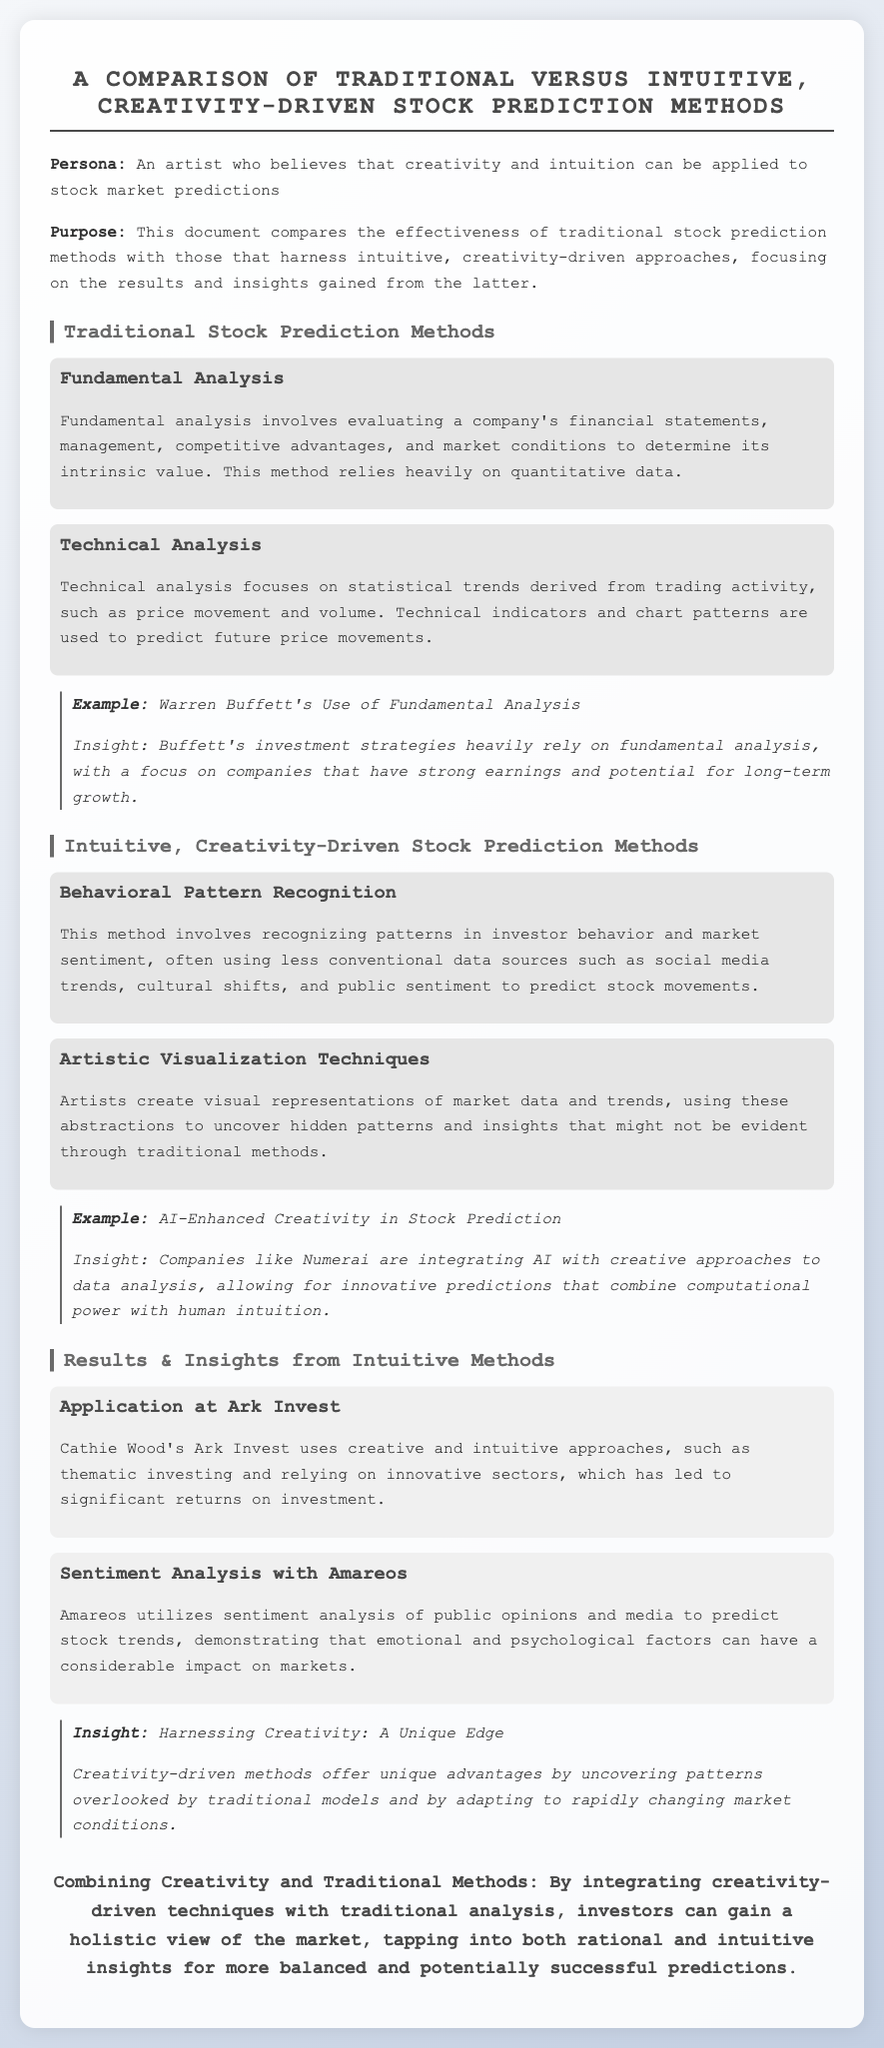What is the document's title? The title summarizes the main focus of the document, highlighting a comparison between two stock prediction methods.
Answer: A Comparison of Traditional versus Intuitive, Creativity-Driven Stock Prediction Methods Who is the persona described in the document? The persona mentioned represents an individual's belief in using creativity for stock market predictions.
Answer: An artist What is a key method used in Traditional Stock Prediction? It describes a method that evaluates financial statements and market conditions, crucial for traditional approaches.
Answer: Fundamental Analysis What unique technique is highlighted in Intuitive, Creativity-Driven methods? This approach emphasizes recognizing patterns in investor behavior and sentiment using unconventional data.
Answer: Behavioral Pattern Recognition Who is associated with significant returns in a case study? The document provides insights into an investment firm led by a notable investor known for innovative strategies.
Answer: Cathie Wood's Ark Invest What does Amareos use to predict stock trends? This application offers a unique approach to analyzing stocks using psychological elements.
Answer: Sentiment analysis of public opinions and media What is the main advantage of creativity-driven methods according to the document? This advantage suggests that less conventional approaches can reveal more about market dynamics.
Answer: Uncovering patterns overlooked by traditional models What combines with traditional methods for improved predictions? The document concludes by suggesting a strategy that brings together different analytical approaches for better market understanding.
Answer: Creativity-driven techniques 